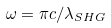<formula> <loc_0><loc_0><loc_500><loc_500>\omega = \pi c / \lambda _ { S H G }</formula> 